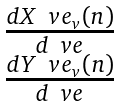<formula> <loc_0><loc_0><loc_500><loc_500>\begin{matrix} \frac { d X ^ { \ } v e _ { v } ( n ) } { d \ v e } \\ \frac { d Y ^ { \ } v e _ { v } ( n ) } { d \ v e } \end{matrix}</formula> 